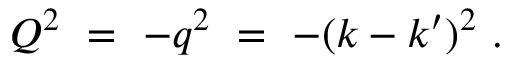Convert formula to latex. <formula><loc_0><loc_0><loc_500><loc_500>Q ^ { 2 } \ = \ - q ^ { 2 } \ = \ - ( k - k ^ { \prime } ) ^ { 2 } \ .</formula> 